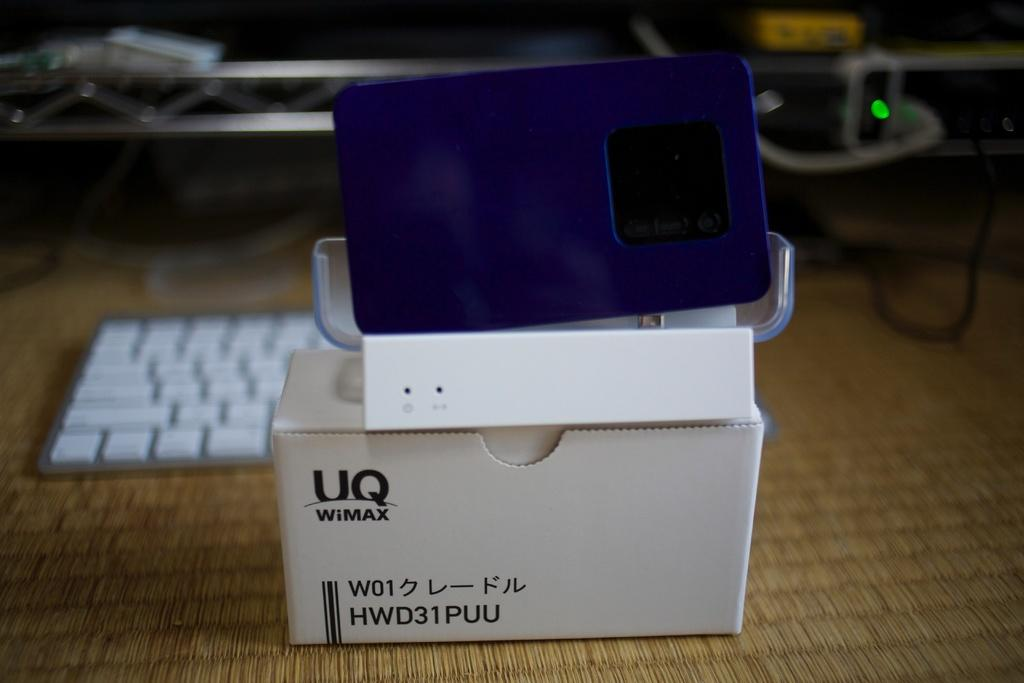<image>
Share a concise interpretation of the image provided. UQ WiMAX HWD31PUU is printed onto the side of this box. 